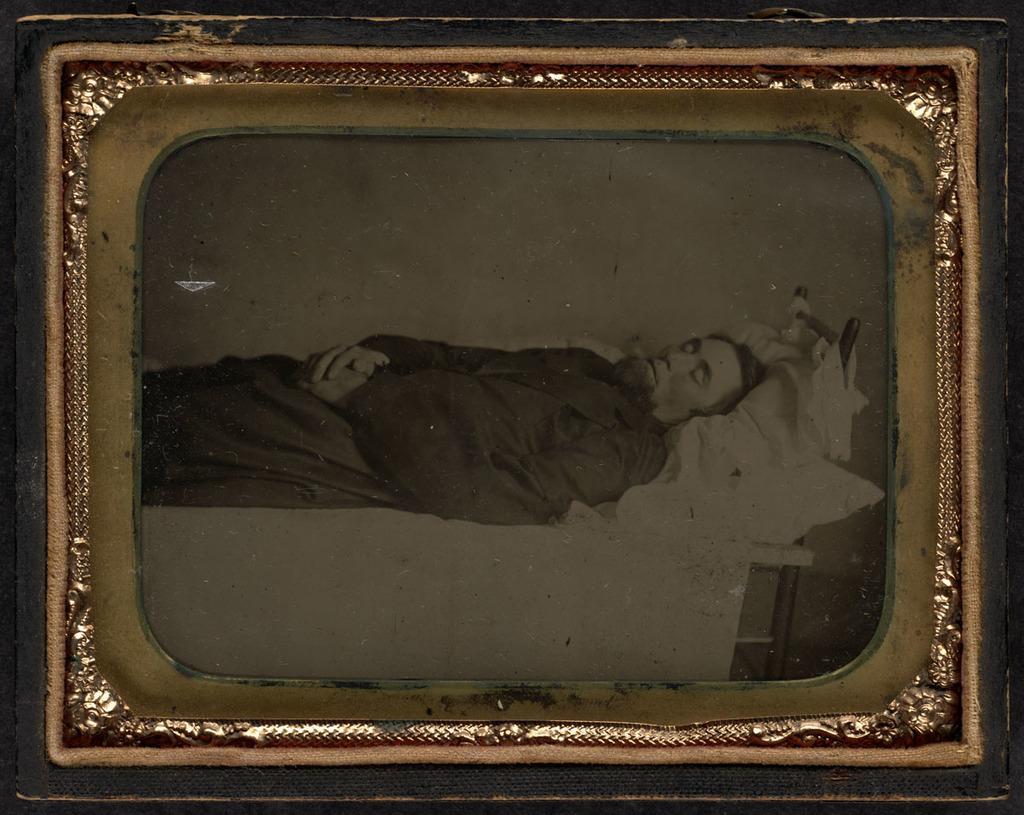In one or two sentences, can you explain what this image depicts? In this picture we can see a photo frame and in this frame we can see a person standing. 